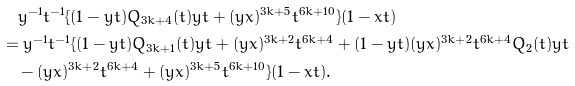<formula> <loc_0><loc_0><loc_500><loc_500>& \quad y ^ { - 1 } t ^ { - 1 } \{ ( 1 - y t ) Q _ { 3 k + 4 } ( t ) y t + ( y x ) ^ { 3 k + 5 } t ^ { 6 k + 1 0 } \} ( 1 - x t ) \\ & = y ^ { - 1 } t ^ { - 1 } \{ ( 1 - y t ) Q _ { 3 k + 1 } ( t ) y t + ( y x ) ^ { 3 k + 2 } t ^ { 6 k + 4 } + ( 1 - y t ) ( y x ) ^ { 3 k + 2 } t ^ { 6 k + 4 } Q _ { 2 } ( t ) y t \\ & \quad - ( y x ) ^ { 3 k + 2 } t ^ { 6 k + 4 } + ( y x ) ^ { 3 k + 5 } t ^ { 6 k + 1 0 } \} ( 1 - x t ) .</formula> 